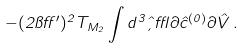<formula> <loc_0><loc_0><loc_500><loc_500>- ( 2 \pi \alpha ^ { \prime } ) ^ { 2 } T _ { M _ { 2 } } \int d ^ { 3 } \hat { \xi } \epsilon \partial { \hat { c } } ^ { ( 0 ) } \partial { \hat { V } } \, .</formula> 